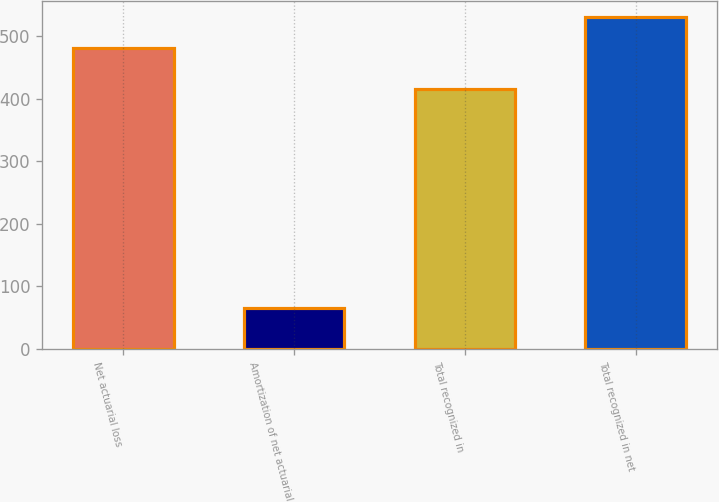<chart> <loc_0><loc_0><loc_500><loc_500><bar_chart><fcel>Net actuarial loss<fcel>Amortization of net actuarial<fcel>Total recognized in<fcel>Total recognized in net<nl><fcel>481<fcel>65<fcel>416<fcel>530<nl></chart> 